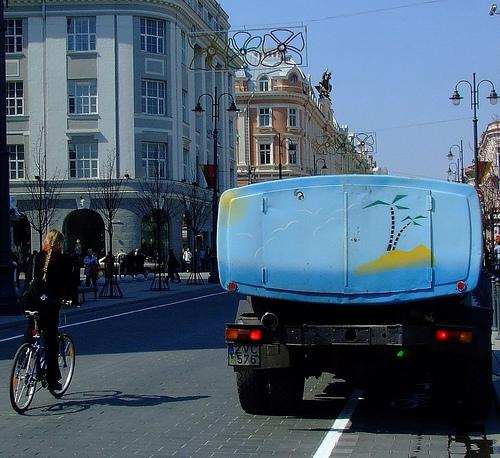Question: when was this picture taken?
Choices:
A. At night.
B. At dawn.
C. During the day.
D. At dusk.
Answer with the letter. Answer: C Question: who is on the bike?
Choices:
A. A lady.
B. A man.
C. A boy.
D. A girl.
Answer with the letter. Answer: A Question: why is the lights red?
Choices:
A. They tell cars to stop.
B. They tell cars to go.
C. They tell cars to show caution.
D. The truck is stopping.
Answer with the letter. Answer: D 